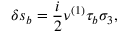Convert formula to latex. <formula><loc_0><loc_0><loc_500><loc_500>\delta s _ { b } = \frac { i } { 2 } \nu ^ { \left ( 1 \right ) } \tau _ { b } \sigma _ { 3 } ,</formula> 